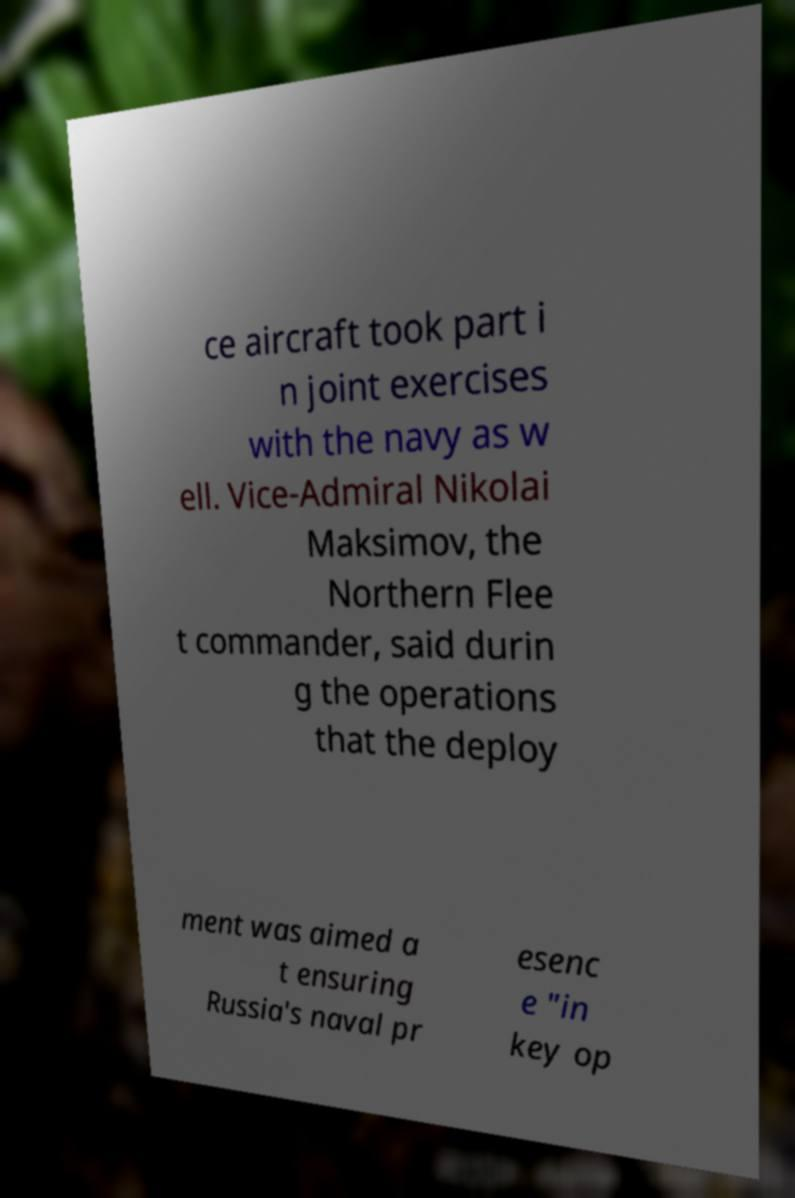I need the written content from this picture converted into text. Can you do that? ce aircraft took part i n joint exercises with the navy as w ell. Vice-Admiral Nikolai Maksimov, the Northern Flee t commander, said durin g the operations that the deploy ment was aimed a t ensuring Russia's naval pr esenc e "in key op 